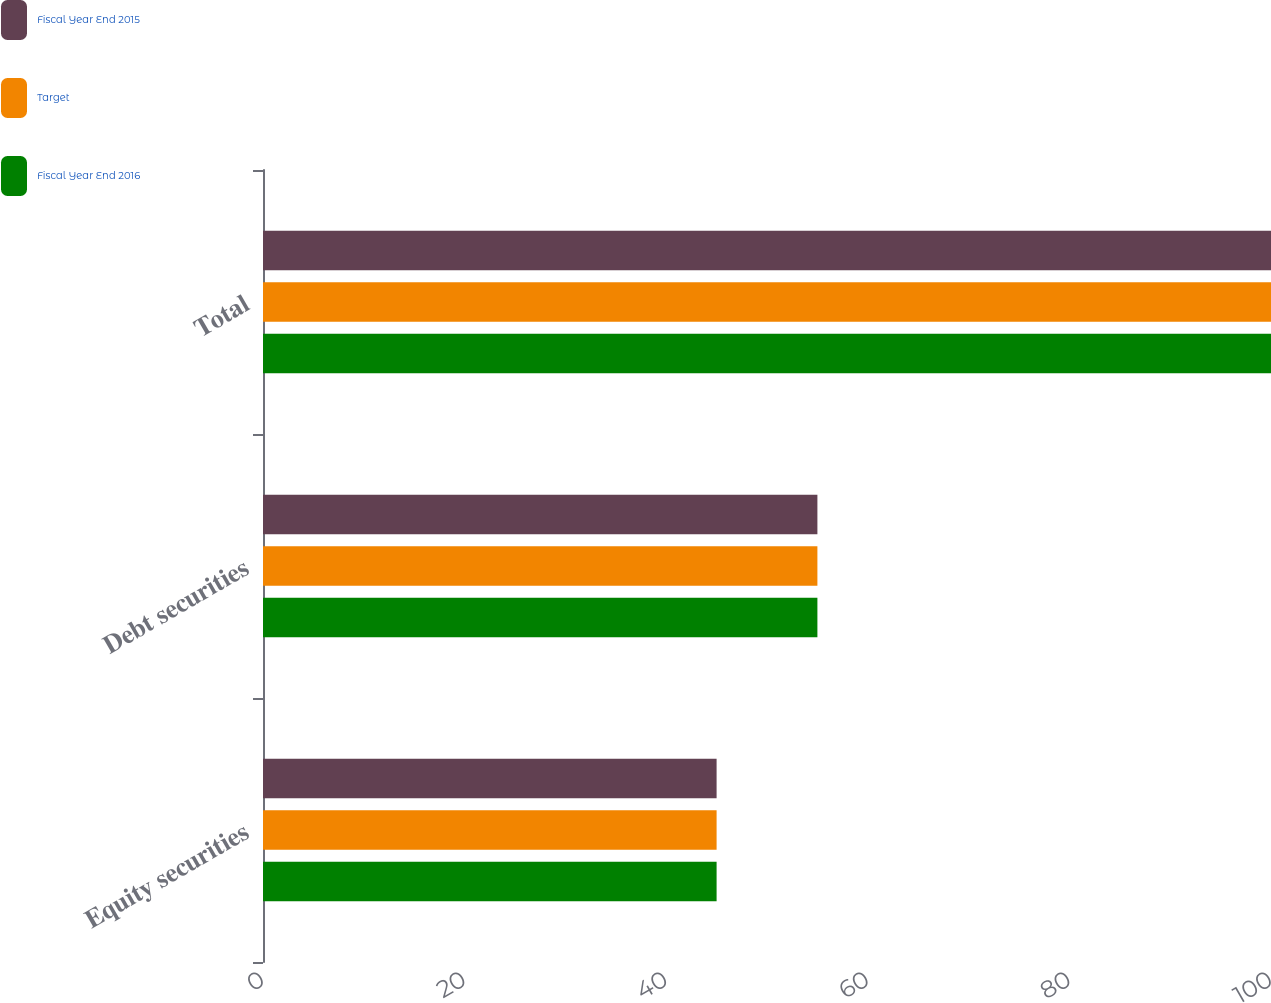Convert chart to OTSL. <chart><loc_0><loc_0><loc_500><loc_500><stacked_bar_chart><ecel><fcel>Equity securities<fcel>Debt securities<fcel>Total<nl><fcel>Fiscal Year End 2015<fcel>45<fcel>55<fcel>100<nl><fcel>Target<fcel>45<fcel>55<fcel>100<nl><fcel>Fiscal Year End 2016<fcel>45<fcel>55<fcel>100<nl></chart> 